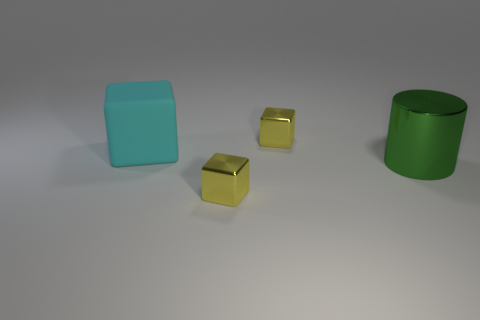Can you infer anything about the texture of the objects? Yes, the objects seem to have different textures. The cyan matte object and the green cylinder have surfaces that look smooth, but not reflective, suggesting a matte finish. In contrast, the smaller gold cubes have a shiny texture, which suggests they have a smoother and possibly metallic finish.  How can you tell the difference in texture? The difference in texture is evident through the way light interacts with the surfaces of the objects. Matte surfaces scatter light, reducing reflections and giving the objects a duller appearance. Reflective surfaces, like those of the smaller gold cubes, create clear highlights and reflections, indicating a smoother finish that can bounce light back more directly. 